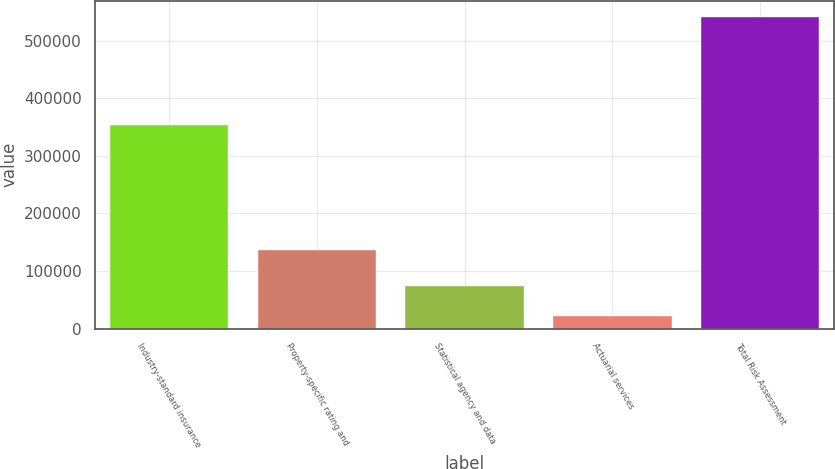Convert chart. <chart><loc_0><loc_0><loc_500><loc_500><bar_chart><fcel>Industry-standard insurance<fcel>Property-specific rating and<fcel>Statistical agency and data<fcel>Actuarial services<fcel>Total Risk Assessment<nl><fcel>353501<fcel>137071<fcel>74201.9<fcel>22209<fcel>542138<nl></chart> 